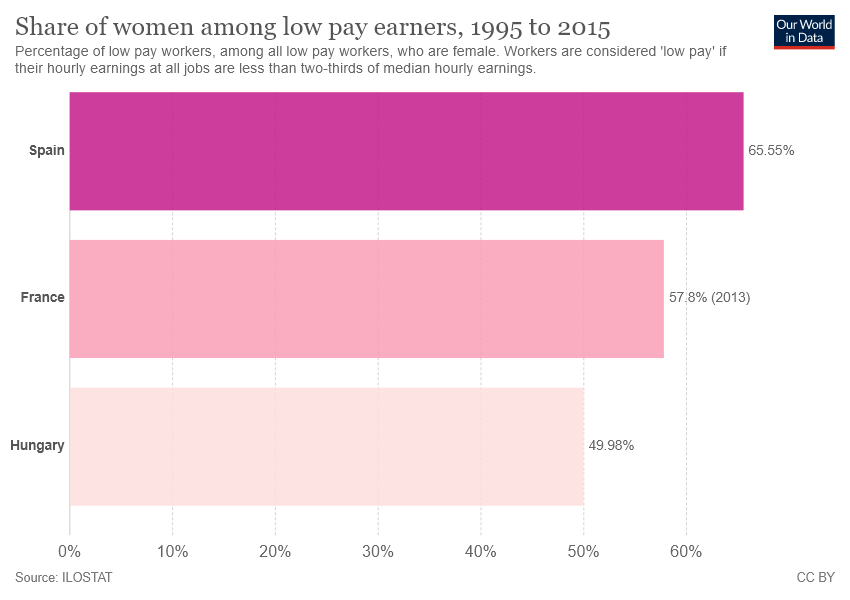Draw attention to some important aspects in this diagram. The value of Spain is 7.75 compared to France. Hungary has the smallest value among all countries. 